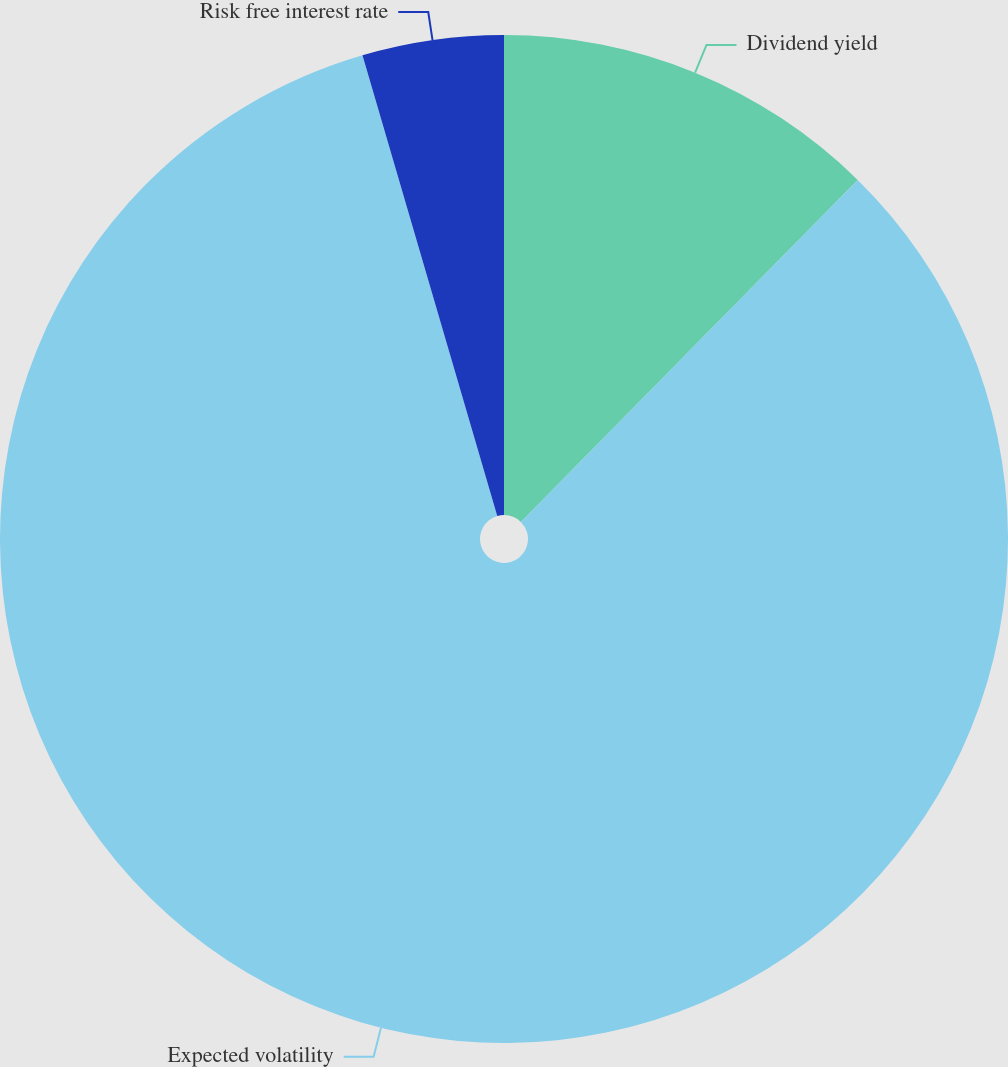Convert chart to OTSL. <chart><loc_0><loc_0><loc_500><loc_500><pie_chart><fcel>Dividend yield<fcel>Expected volatility<fcel>Risk free interest rate<nl><fcel>12.38%<fcel>83.09%<fcel>4.53%<nl></chart> 